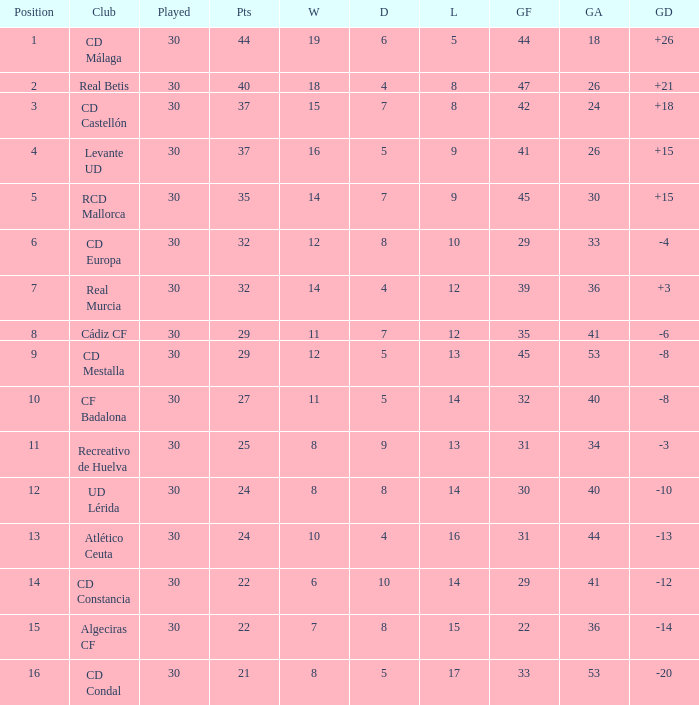What is the number of losses when the goal difference was -8, and position is smaller than 10? 1.0. 